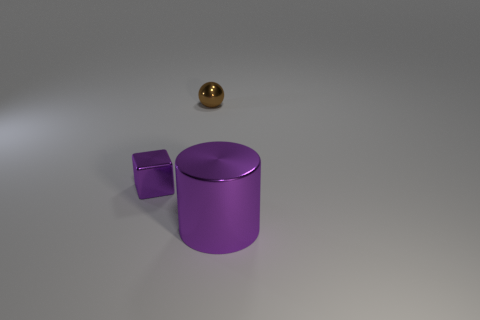How many other small brown shiny objects have the same shape as the brown object?
Your response must be concise. 0. There is a sphere that is the same material as the purple cube; what is its size?
Offer a very short reply. Small. How many brown shiny things have the same size as the cube?
Offer a terse response. 1. What size is the metal cylinder that is the same color as the cube?
Offer a very short reply. Large. There is a small metal object that is to the right of the purple object that is left of the large cylinder; what is its color?
Keep it short and to the point. Brown. Are there any metallic cylinders of the same color as the small block?
Offer a terse response. Yes. The thing that is the same size as the brown sphere is what color?
Offer a very short reply. Purple. Is the material of the thing that is to the left of the small brown metal sphere the same as the ball?
Make the answer very short. Yes. Are there any large purple metallic cylinders to the right of the tiny metal thing behind the purple metal thing behind the purple cylinder?
Offer a very short reply. Yes. Is the shape of the purple thing on the right side of the small brown shiny object the same as  the small purple object?
Ensure brevity in your answer.  No. 